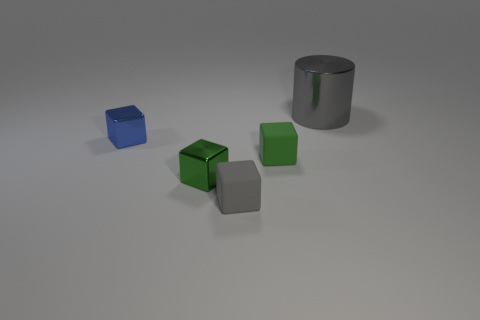Subtract all purple cylinders. How many green blocks are left? 2 Add 1 tiny gray rubber objects. How many objects exist? 6 Subtract all small blue cubes. How many cubes are left? 3 Subtract all blue blocks. How many blocks are left? 3 Subtract all yellow cubes. Subtract all purple spheres. How many cubes are left? 4 Subtract all cylinders. How many objects are left? 4 Subtract all tiny rubber objects. Subtract all rubber objects. How many objects are left? 1 Add 4 rubber blocks. How many rubber blocks are left? 6 Add 2 yellow objects. How many yellow objects exist? 2 Subtract 0 yellow spheres. How many objects are left? 5 